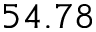Convert formula to latex. <formula><loc_0><loc_0><loc_500><loc_500>5 4 . 7 8</formula> 